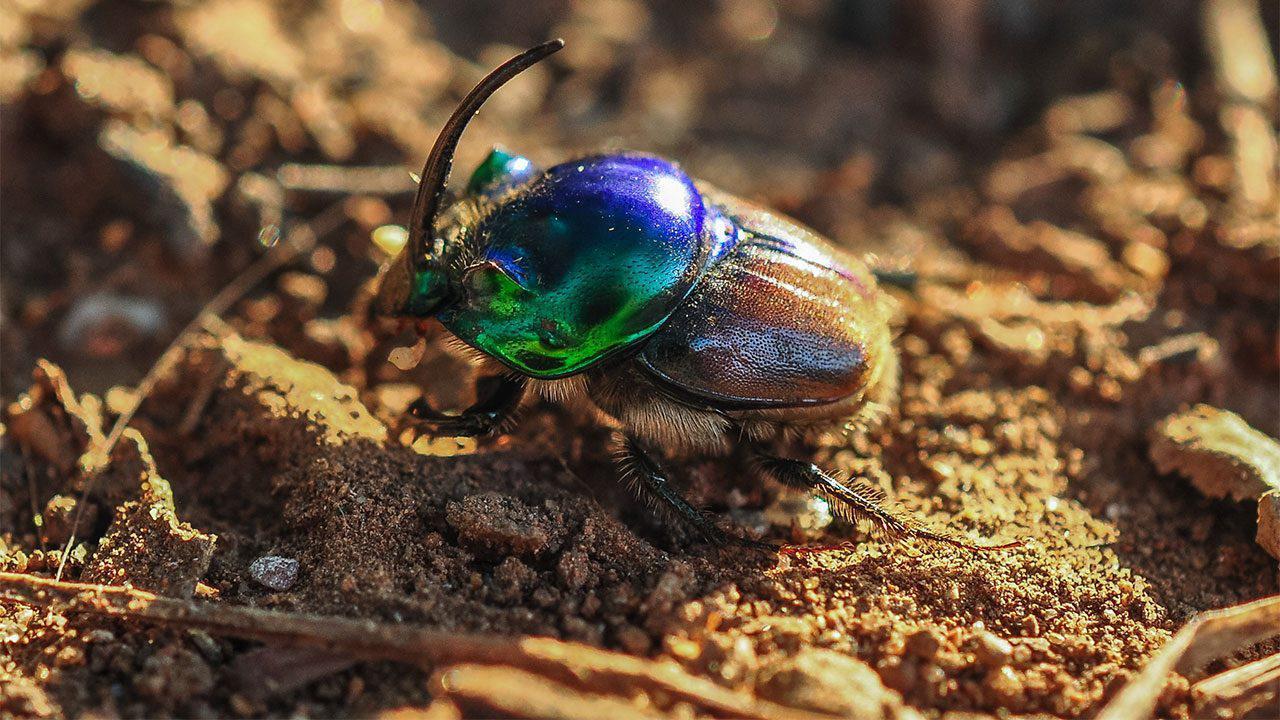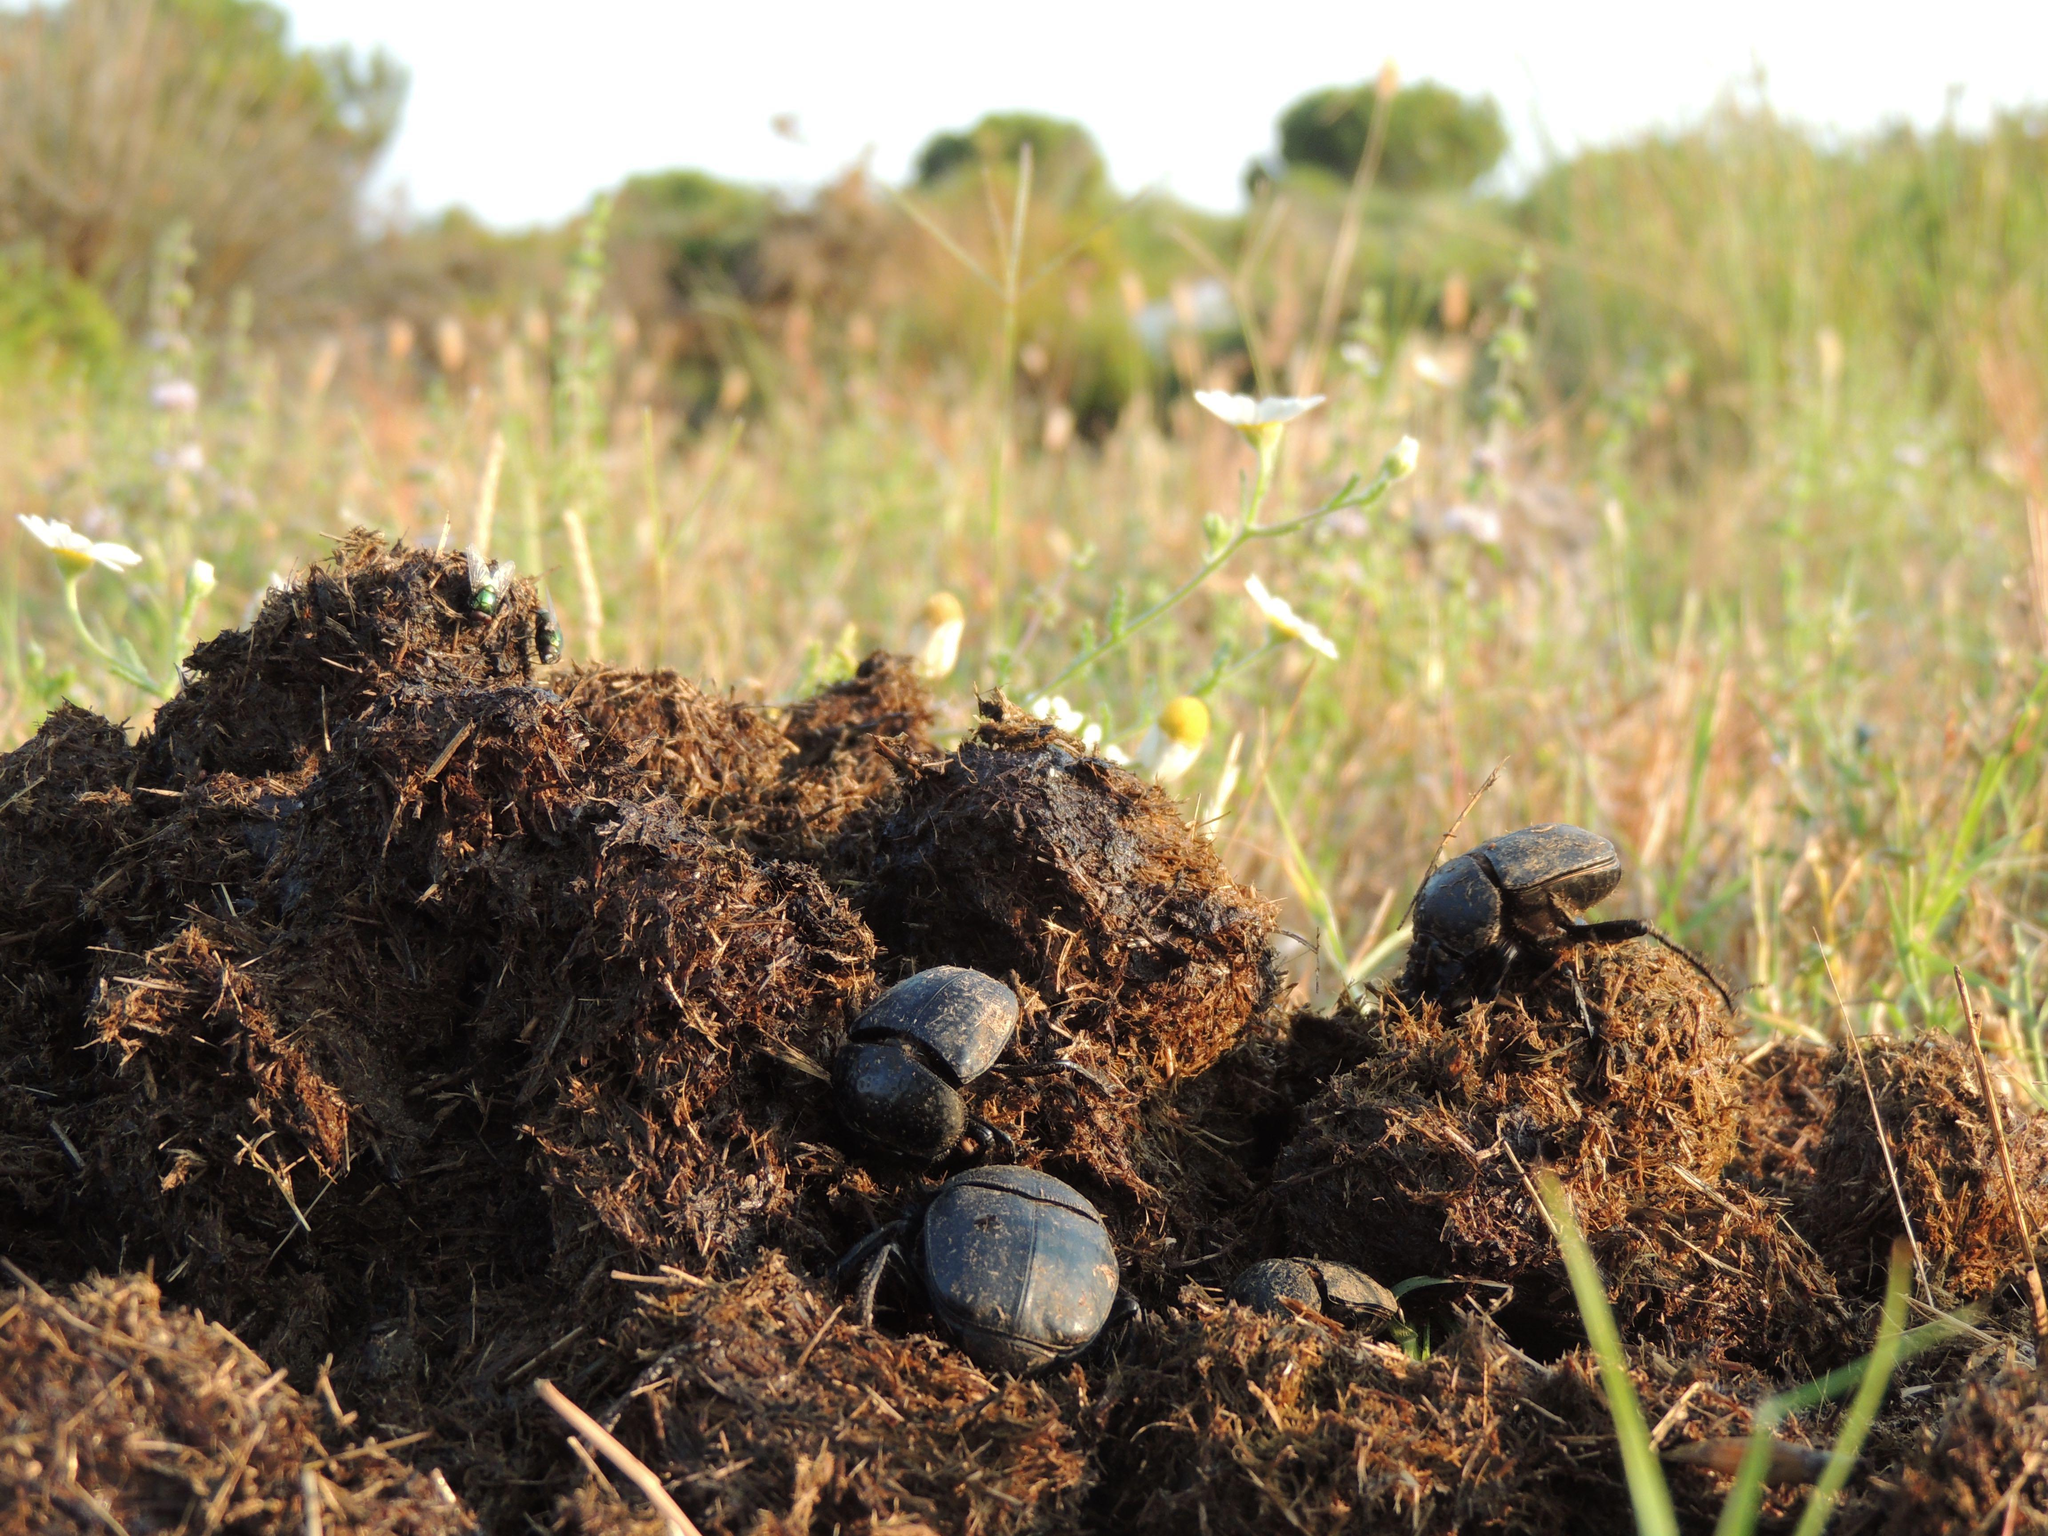The first image is the image on the left, the second image is the image on the right. Given the left and right images, does the statement "An image shows exactly two black beetles by one dung ball." hold true? Answer yes or no. No. The first image is the image on the left, the second image is the image on the right. Evaluate the accuracy of this statement regarding the images: "One of the images shows a single beetle pushing a dungball from the left.". Is it true? Answer yes or no. No. 